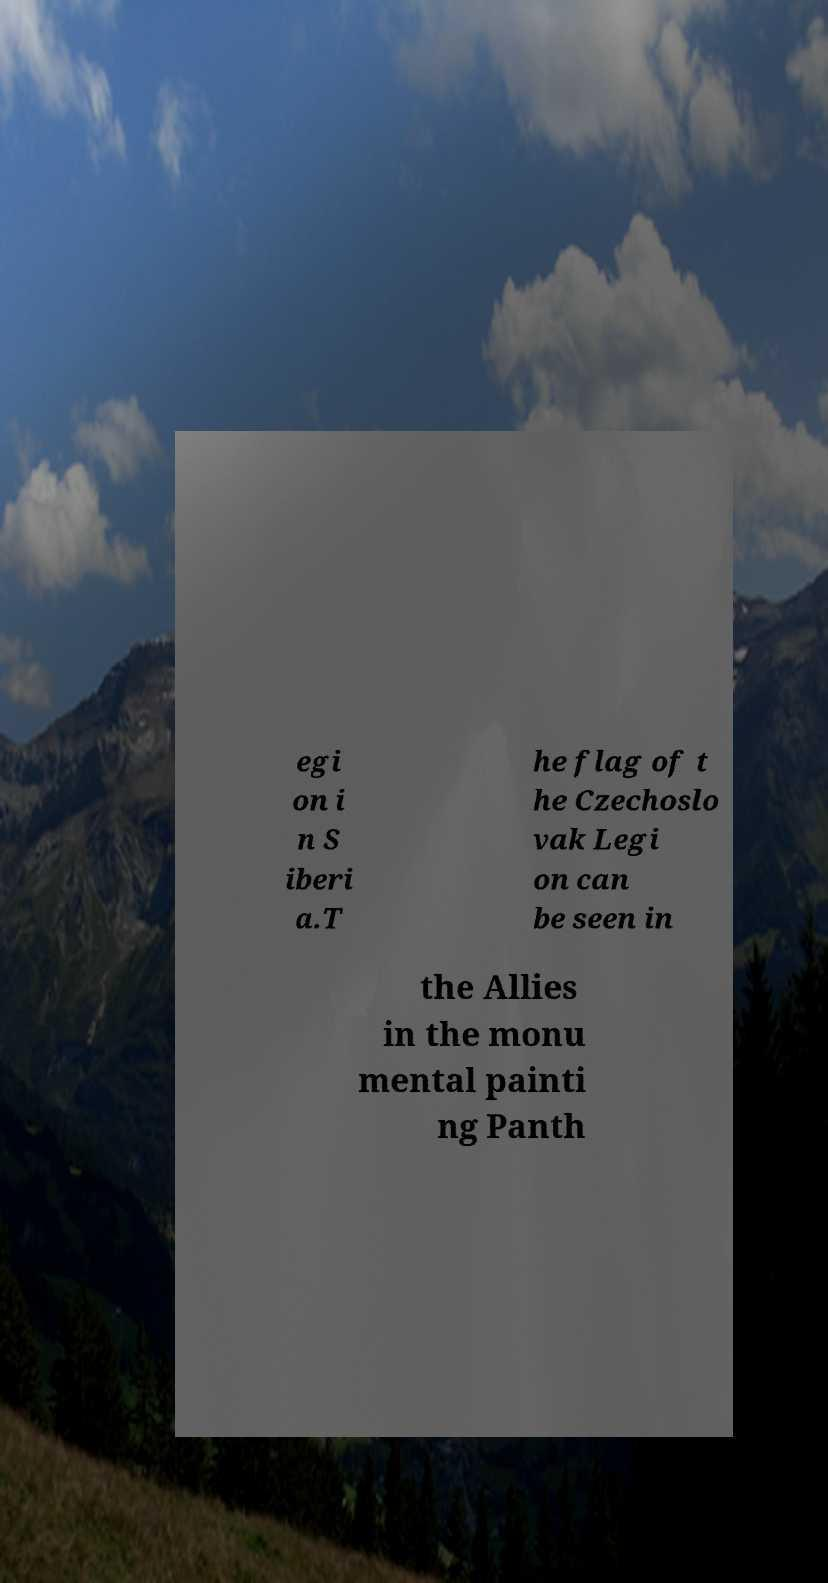I need the written content from this picture converted into text. Can you do that? egi on i n S iberi a.T he flag of t he Czechoslo vak Legi on can be seen in the Allies in the monu mental painti ng Panth 